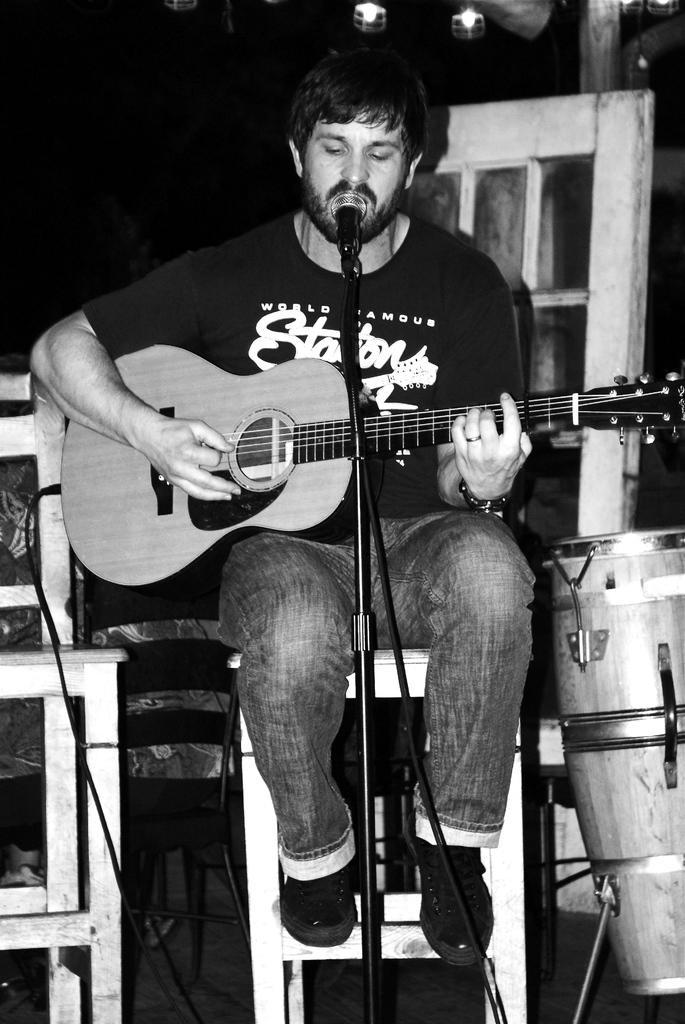Could you give a brief overview of what you see in this image? In this picture, there is a man sitting on chair and playing guitar. In front of him there is a microphone and microphone stand. Beside to him there is drum placed on drum stand. There are cables attached to the guitar. Behind him there are lights and window. 